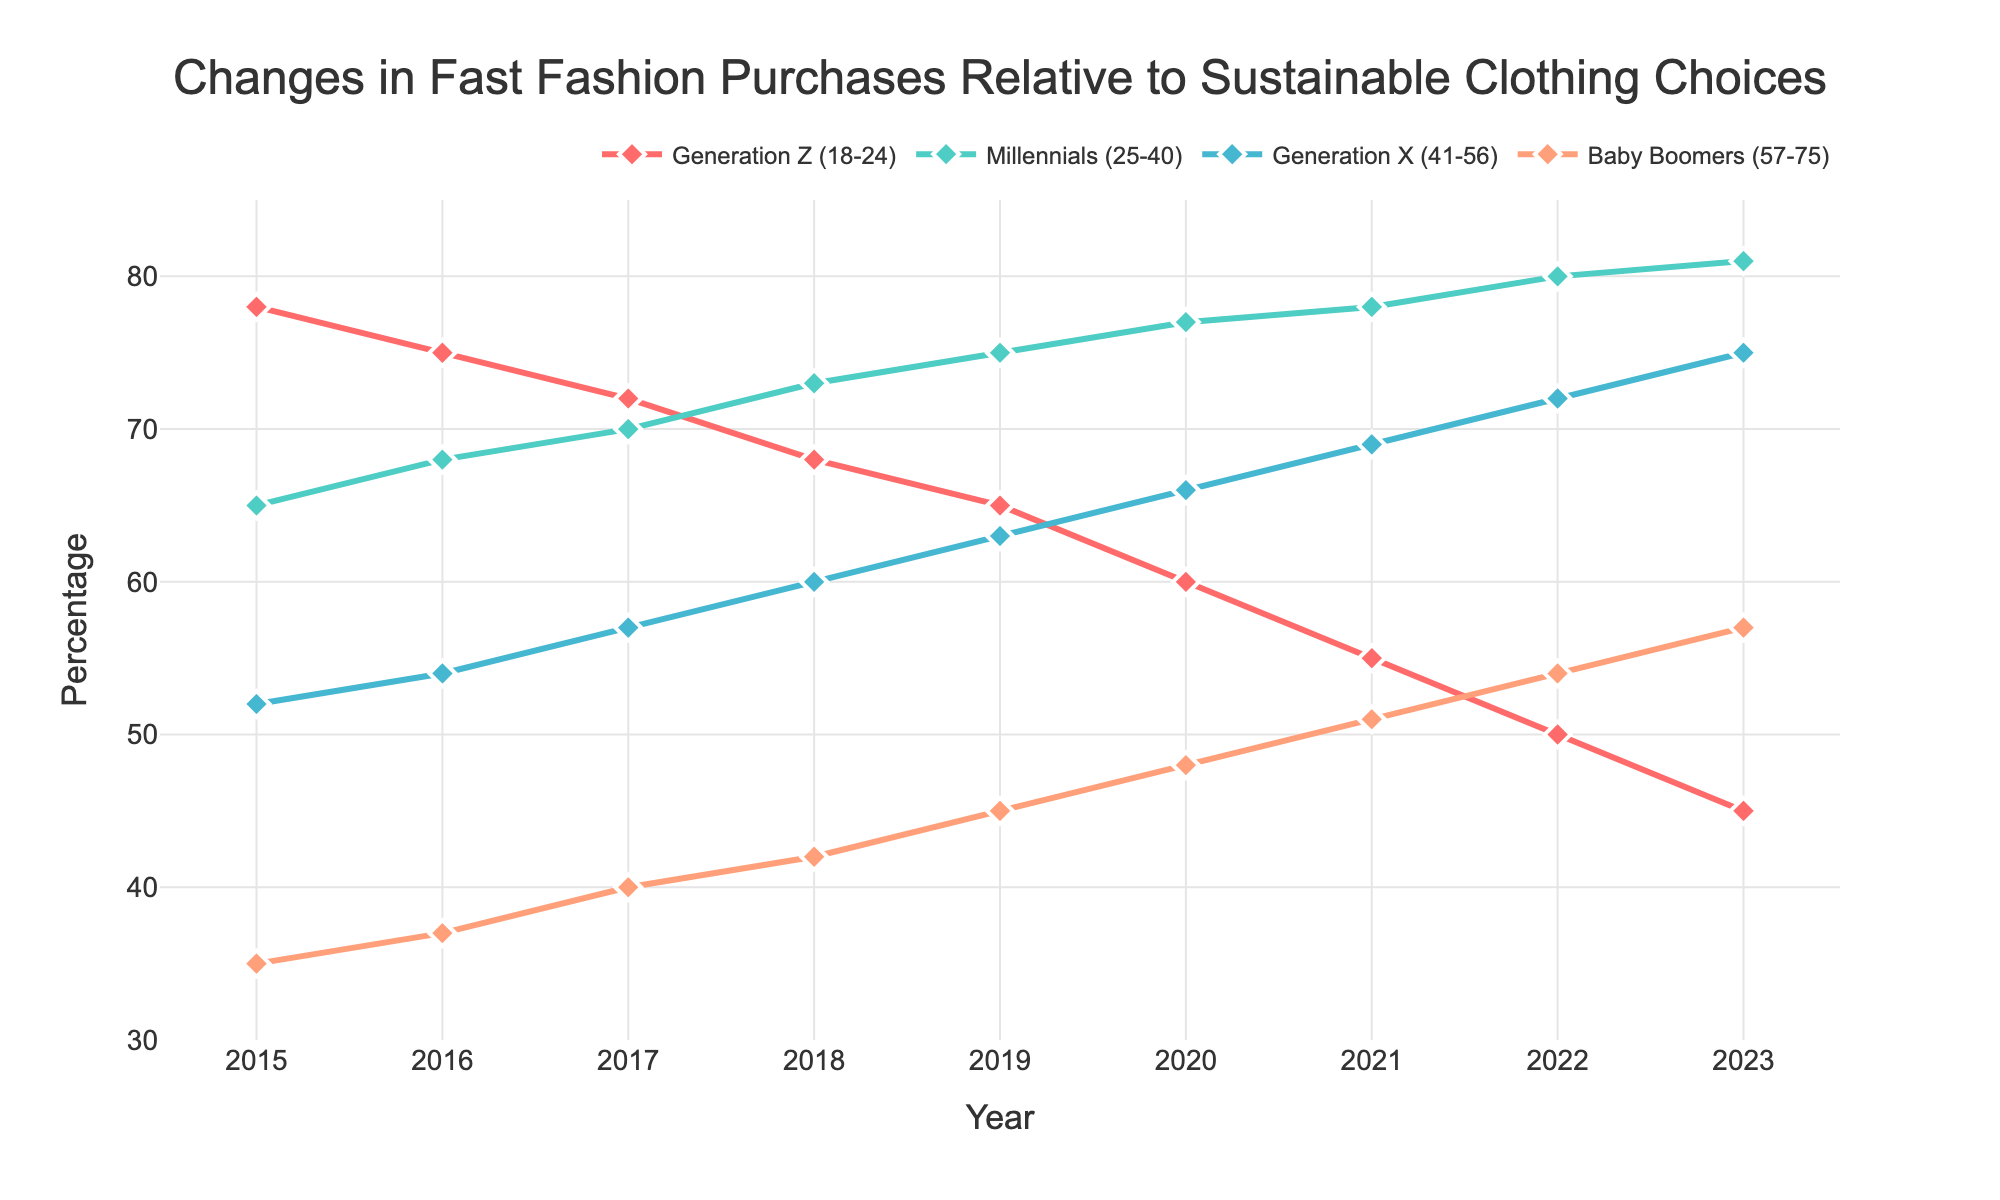what year did Generation Z have the highest percentage of fast fashion purchases? To determine the year when Generation Z had the highest percentage of fast fashion purchases, observe the line representing Generation Z on the chart. The peak value occurs in 2015.
Answer: 2015 In 2023, which generation had the lowest percentage of fast fashion purchases? Look at the data points for 2023 and compare the values for each generation. Generation Z had the lowest percentage at 45%.
Answer: Generation Z How do Baby Boomers' fast fashion purchases in 2015 compare to those in 2023? Compare the values for Baby Boomers between 2015 and 2023. In 2015 it was 35%, and in 2023 it was 57%.
Answer: Increased by 22% Which two generations showed the most consistent increase in fast fashion purchases over the period? Identify the generations with a steady upward trend year-by-year in the chart. Baby Boomers and Generation X show consistent increases.
Answer: Baby Boomers and Generation X What is the average percentage change in fast fashion purchases for Millennials between 2015 and 2023? Calculate the percentage points across years for Millennials and find the average change. (81% - 65%) / (2023 - 2015) = 16 / 8 = 2% per year.
Answer: 2% per year In which year did Millennials overtake Generation Z in fast fashion purchases? Examine the lines for Millennials and Generation Z to see where Millennials' line exceeds Generation Z's. This occurs in 2016.
Answer: 2016 What is the overall trend for Generation X's fast fashion purchases from 2015 to 2023? Observe the line representing Generation X. It consistently rises from 52% to 75% from 2015 to 2023.
Answer: Increasing Compare the percentage of fast fashion purchases between Gen Z and Millennials in 2021. Which is higher? Look at the values for both generations in 2021. Generation Z is at 55% while Millennials are at 78%.
Answer: Millennials are higher Which generation had the most dramatic decline in fast fashion purchases from 2015 to 2023? Compare the decline across all generations by calculating the differences. Generation Z fell from 78% to 45%, the steepest decline overall.
Answer: Generation Z 